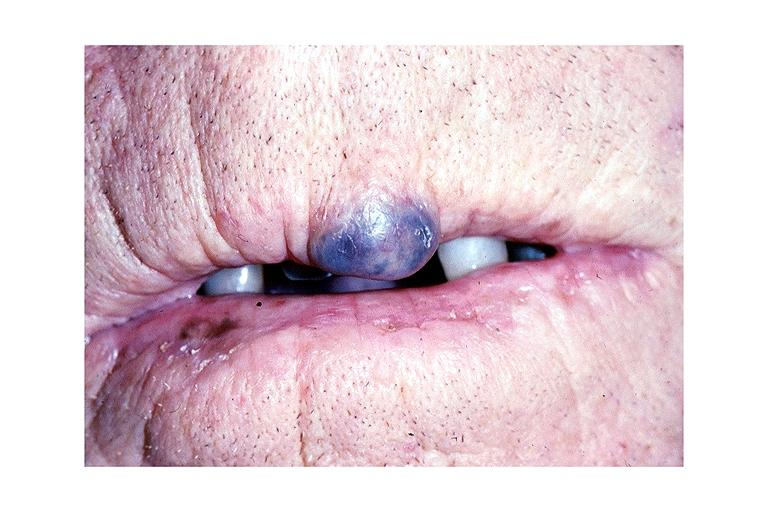what does this image show?
Answer the question using a single word or phrase. Hemangioma 